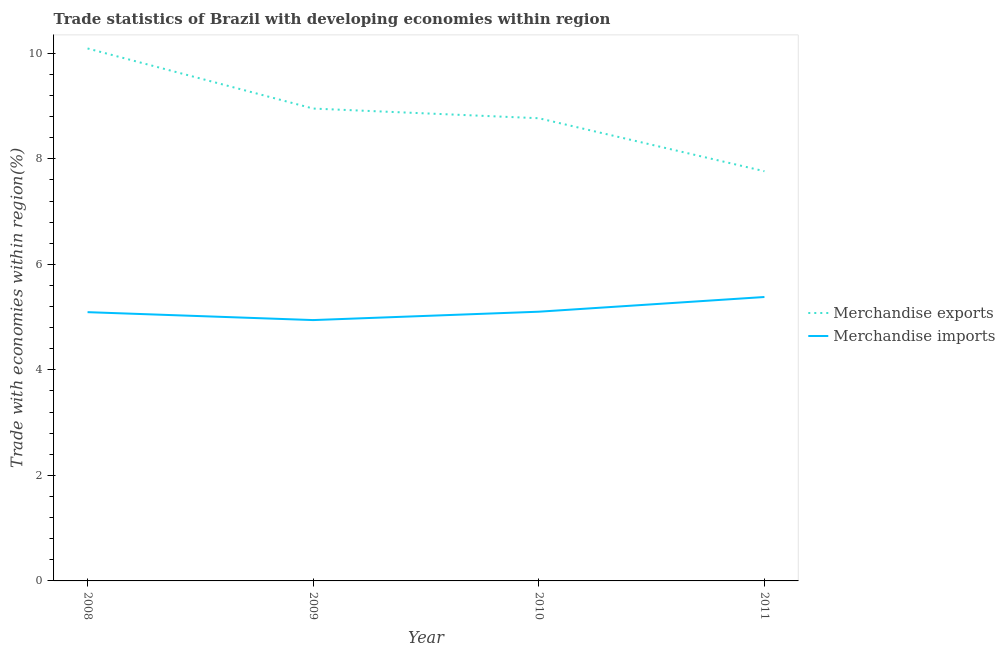Is the number of lines equal to the number of legend labels?
Make the answer very short. Yes. What is the merchandise imports in 2008?
Ensure brevity in your answer.  5.09. Across all years, what is the maximum merchandise imports?
Ensure brevity in your answer.  5.38. Across all years, what is the minimum merchandise exports?
Ensure brevity in your answer.  7.77. In which year was the merchandise exports minimum?
Make the answer very short. 2011. What is the total merchandise exports in the graph?
Keep it short and to the point. 35.58. What is the difference between the merchandise exports in 2009 and that in 2011?
Your answer should be very brief. 1.19. What is the difference between the merchandise exports in 2011 and the merchandise imports in 2008?
Offer a terse response. 2.67. What is the average merchandise exports per year?
Provide a succinct answer. 8.9. In the year 2009, what is the difference between the merchandise imports and merchandise exports?
Provide a short and direct response. -4.01. What is the ratio of the merchandise exports in 2008 to that in 2010?
Provide a succinct answer. 1.15. What is the difference between the highest and the second highest merchandise imports?
Offer a very short reply. 0.28. What is the difference between the highest and the lowest merchandise imports?
Your answer should be compact. 0.44. Is the sum of the merchandise imports in 2008 and 2010 greater than the maximum merchandise exports across all years?
Your response must be concise. Yes. Does the merchandise exports monotonically increase over the years?
Offer a very short reply. No. How many years are there in the graph?
Provide a short and direct response. 4. Are the values on the major ticks of Y-axis written in scientific E-notation?
Ensure brevity in your answer.  No. Does the graph contain any zero values?
Give a very brief answer. No. How many legend labels are there?
Give a very brief answer. 2. How are the legend labels stacked?
Make the answer very short. Vertical. What is the title of the graph?
Offer a very short reply. Trade statistics of Brazil with developing economies within region. What is the label or title of the X-axis?
Your answer should be compact. Year. What is the label or title of the Y-axis?
Your answer should be very brief. Trade with economies within region(%). What is the Trade with economies within region(%) in Merchandise exports in 2008?
Offer a very short reply. 10.09. What is the Trade with economies within region(%) of Merchandise imports in 2008?
Your response must be concise. 5.09. What is the Trade with economies within region(%) in Merchandise exports in 2009?
Give a very brief answer. 8.95. What is the Trade with economies within region(%) in Merchandise imports in 2009?
Make the answer very short. 4.94. What is the Trade with economies within region(%) in Merchandise exports in 2010?
Keep it short and to the point. 8.77. What is the Trade with economies within region(%) of Merchandise imports in 2010?
Your response must be concise. 5.1. What is the Trade with economies within region(%) in Merchandise exports in 2011?
Make the answer very short. 7.77. What is the Trade with economies within region(%) of Merchandise imports in 2011?
Ensure brevity in your answer.  5.38. Across all years, what is the maximum Trade with economies within region(%) of Merchandise exports?
Offer a very short reply. 10.09. Across all years, what is the maximum Trade with economies within region(%) of Merchandise imports?
Ensure brevity in your answer.  5.38. Across all years, what is the minimum Trade with economies within region(%) in Merchandise exports?
Your response must be concise. 7.77. Across all years, what is the minimum Trade with economies within region(%) in Merchandise imports?
Ensure brevity in your answer.  4.94. What is the total Trade with economies within region(%) of Merchandise exports in the graph?
Offer a very short reply. 35.58. What is the total Trade with economies within region(%) of Merchandise imports in the graph?
Give a very brief answer. 20.52. What is the difference between the Trade with economies within region(%) of Merchandise exports in 2008 and that in 2009?
Offer a very short reply. 1.14. What is the difference between the Trade with economies within region(%) in Merchandise imports in 2008 and that in 2009?
Keep it short and to the point. 0.15. What is the difference between the Trade with economies within region(%) in Merchandise exports in 2008 and that in 2010?
Your answer should be very brief. 1.32. What is the difference between the Trade with economies within region(%) of Merchandise imports in 2008 and that in 2010?
Make the answer very short. -0.01. What is the difference between the Trade with economies within region(%) in Merchandise exports in 2008 and that in 2011?
Make the answer very short. 2.33. What is the difference between the Trade with economies within region(%) of Merchandise imports in 2008 and that in 2011?
Your answer should be very brief. -0.29. What is the difference between the Trade with economies within region(%) in Merchandise exports in 2009 and that in 2010?
Your response must be concise. 0.18. What is the difference between the Trade with economies within region(%) in Merchandise imports in 2009 and that in 2010?
Your response must be concise. -0.16. What is the difference between the Trade with economies within region(%) in Merchandise exports in 2009 and that in 2011?
Keep it short and to the point. 1.19. What is the difference between the Trade with economies within region(%) in Merchandise imports in 2009 and that in 2011?
Your response must be concise. -0.44. What is the difference between the Trade with economies within region(%) of Merchandise imports in 2010 and that in 2011?
Your answer should be compact. -0.28. What is the difference between the Trade with economies within region(%) in Merchandise exports in 2008 and the Trade with economies within region(%) in Merchandise imports in 2009?
Your answer should be very brief. 5.15. What is the difference between the Trade with economies within region(%) in Merchandise exports in 2008 and the Trade with economies within region(%) in Merchandise imports in 2010?
Offer a terse response. 4.99. What is the difference between the Trade with economies within region(%) in Merchandise exports in 2008 and the Trade with economies within region(%) in Merchandise imports in 2011?
Provide a short and direct response. 4.71. What is the difference between the Trade with economies within region(%) of Merchandise exports in 2009 and the Trade with economies within region(%) of Merchandise imports in 2010?
Your answer should be compact. 3.85. What is the difference between the Trade with economies within region(%) of Merchandise exports in 2009 and the Trade with economies within region(%) of Merchandise imports in 2011?
Keep it short and to the point. 3.57. What is the difference between the Trade with economies within region(%) in Merchandise exports in 2010 and the Trade with economies within region(%) in Merchandise imports in 2011?
Your answer should be very brief. 3.39. What is the average Trade with economies within region(%) of Merchandise exports per year?
Give a very brief answer. 8.9. What is the average Trade with economies within region(%) of Merchandise imports per year?
Provide a short and direct response. 5.13. In the year 2008, what is the difference between the Trade with economies within region(%) of Merchandise exports and Trade with economies within region(%) of Merchandise imports?
Keep it short and to the point. 5. In the year 2009, what is the difference between the Trade with economies within region(%) of Merchandise exports and Trade with economies within region(%) of Merchandise imports?
Give a very brief answer. 4.01. In the year 2010, what is the difference between the Trade with economies within region(%) of Merchandise exports and Trade with economies within region(%) of Merchandise imports?
Your answer should be compact. 3.67. In the year 2011, what is the difference between the Trade with economies within region(%) in Merchandise exports and Trade with economies within region(%) in Merchandise imports?
Offer a terse response. 2.38. What is the ratio of the Trade with economies within region(%) in Merchandise exports in 2008 to that in 2009?
Your answer should be very brief. 1.13. What is the ratio of the Trade with economies within region(%) in Merchandise imports in 2008 to that in 2009?
Offer a terse response. 1.03. What is the ratio of the Trade with economies within region(%) of Merchandise exports in 2008 to that in 2010?
Give a very brief answer. 1.15. What is the ratio of the Trade with economies within region(%) in Merchandise exports in 2008 to that in 2011?
Your answer should be compact. 1.3. What is the ratio of the Trade with economies within region(%) in Merchandise imports in 2008 to that in 2011?
Offer a terse response. 0.95. What is the ratio of the Trade with economies within region(%) of Merchandise exports in 2009 to that in 2010?
Provide a short and direct response. 1.02. What is the ratio of the Trade with economies within region(%) in Merchandise imports in 2009 to that in 2010?
Your response must be concise. 0.97. What is the ratio of the Trade with economies within region(%) in Merchandise exports in 2009 to that in 2011?
Offer a terse response. 1.15. What is the ratio of the Trade with economies within region(%) in Merchandise imports in 2009 to that in 2011?
Make the answer very short. 0.92. What is the ratio of the Trade with economies within region(%) of Merchandise exports in 2010 to that in 2011?
Your response must be concise. 1.13. What is the ratio of the Trade with economies within region(%) of Merchandise imports in 2010 to that in 2011?
Your answer should be compact. 0.95. What is the difference between the highest and the second highest Trade with economies within region(%) in Merchandise exports?
Ensure brevity in your answer.  1.14. What is the difference between the highest and the second highest Trade with economies within region(%) in Merchandise imports?
Offer a terse response. 0.28. What is the difference between the highest and the lowest Trade with economies within region(%) of Merchandise exports?
Provide a succinct answer. 2.33. What is the difference between the highest and the lowest Trade with economies within region(%) of Merchandise imports?
Your answer should be very brief. 0.44. 